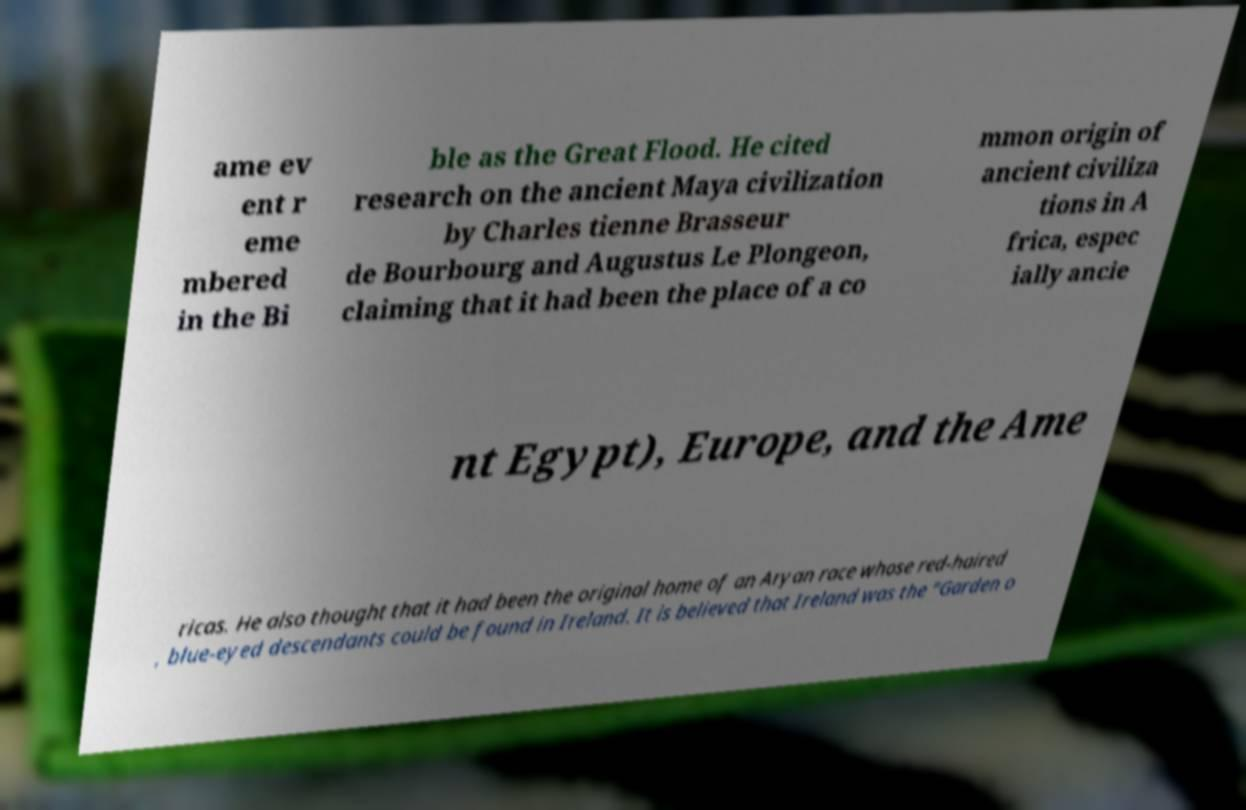Please identify and transcribe the text found in this image. ame ev ent r eme mbered in the Bi ble as the Great Flood. He cited research on the ancient Maya civilization by Charles tienne Brasseur de Bourbourg and Augustus Le Plongeon, claiming that it had been the place of a co mmon origin of ancient civiliza tions in A frica, espec ially ancie nt Egypt), Europe, and the Ame ricas. He also thought that it had been the original home of an Aryan race whose red-haired , blue-eyed descendants could be found in Ireland. It is believed that Ireland was the "Garden o 